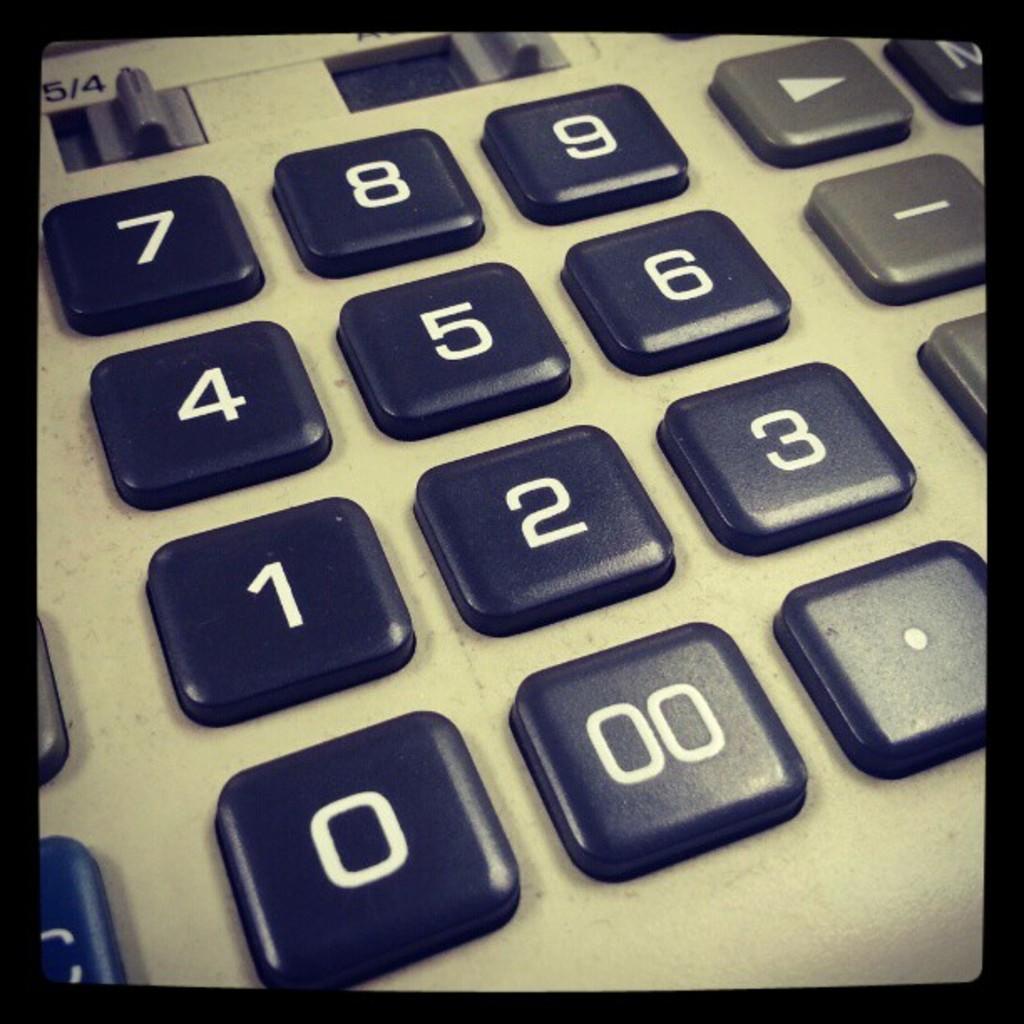What number is directly to the right of the 0?
Your response must be concise. 00. What is the number on the top left?
Your response must be concise. 7. 